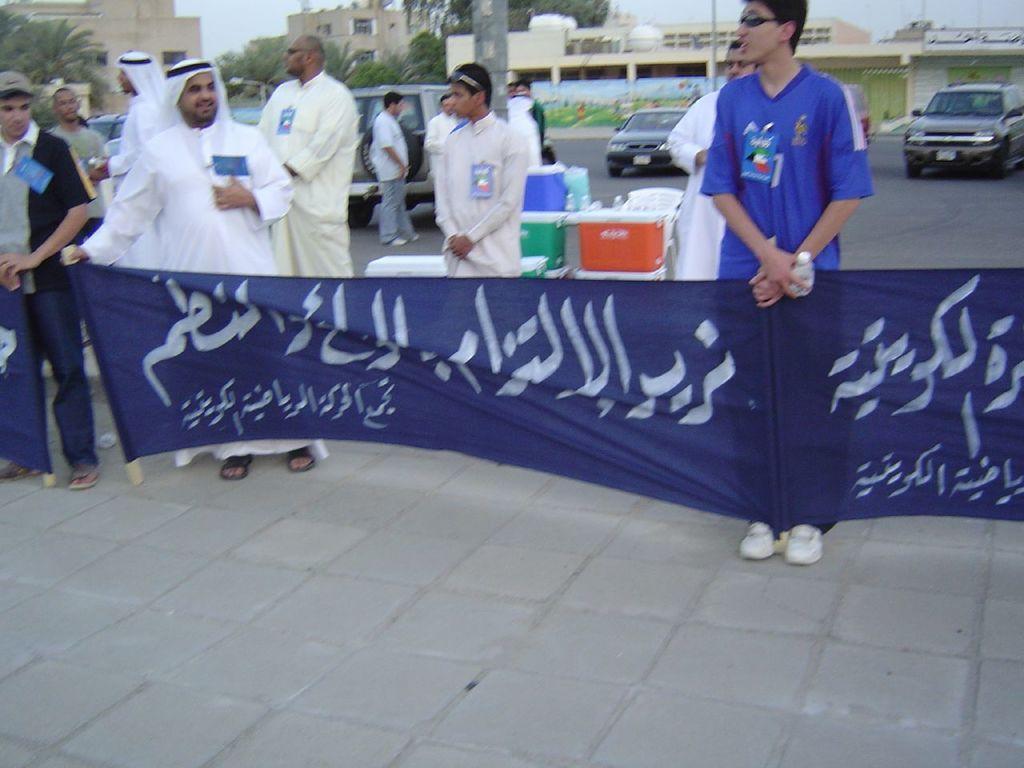Could you give a brief overview of what you see in this image? In this picture we can see some persons are standing on the road. This is cloth. Here we can see some boxes. On the background there are cars on the road. There are buildings and these are the trees. And there is a pole. 